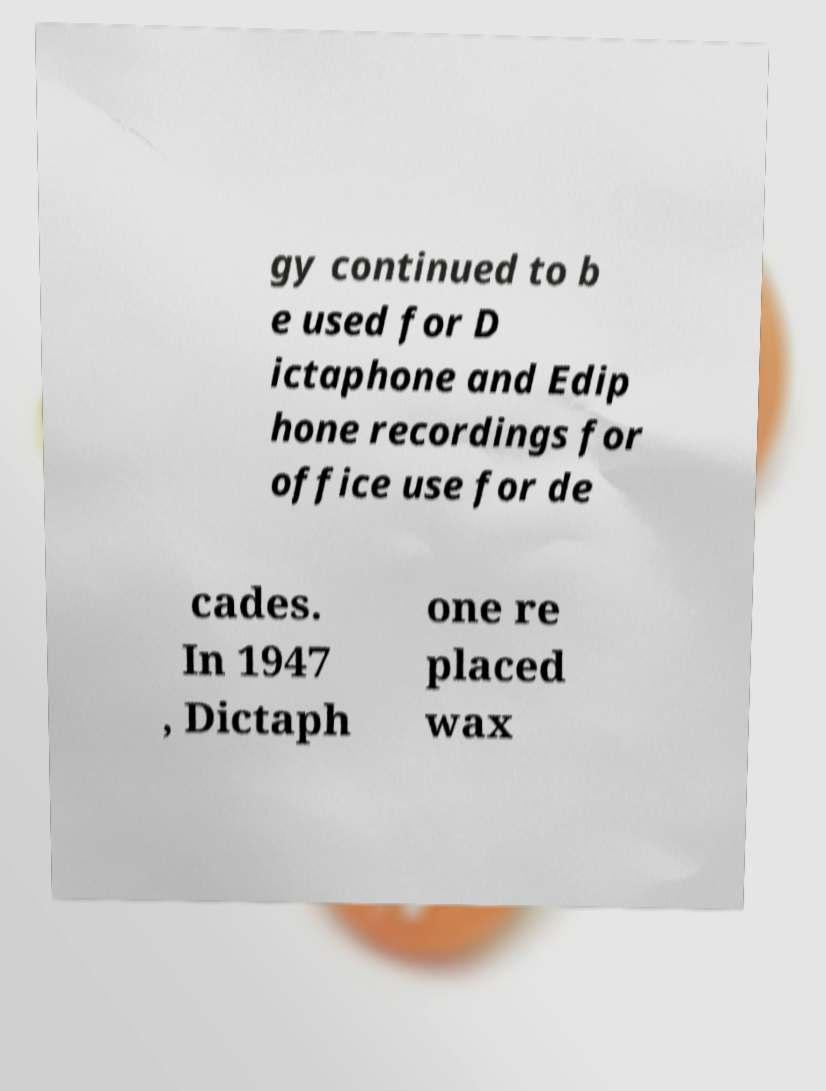Could you assist in decoding the text presented in this image and type it out clearly? gy continued to b e used for D ictaphone and Edip hone recordings for office use for de cades. In 1947 , Dictaph one re placed wax 